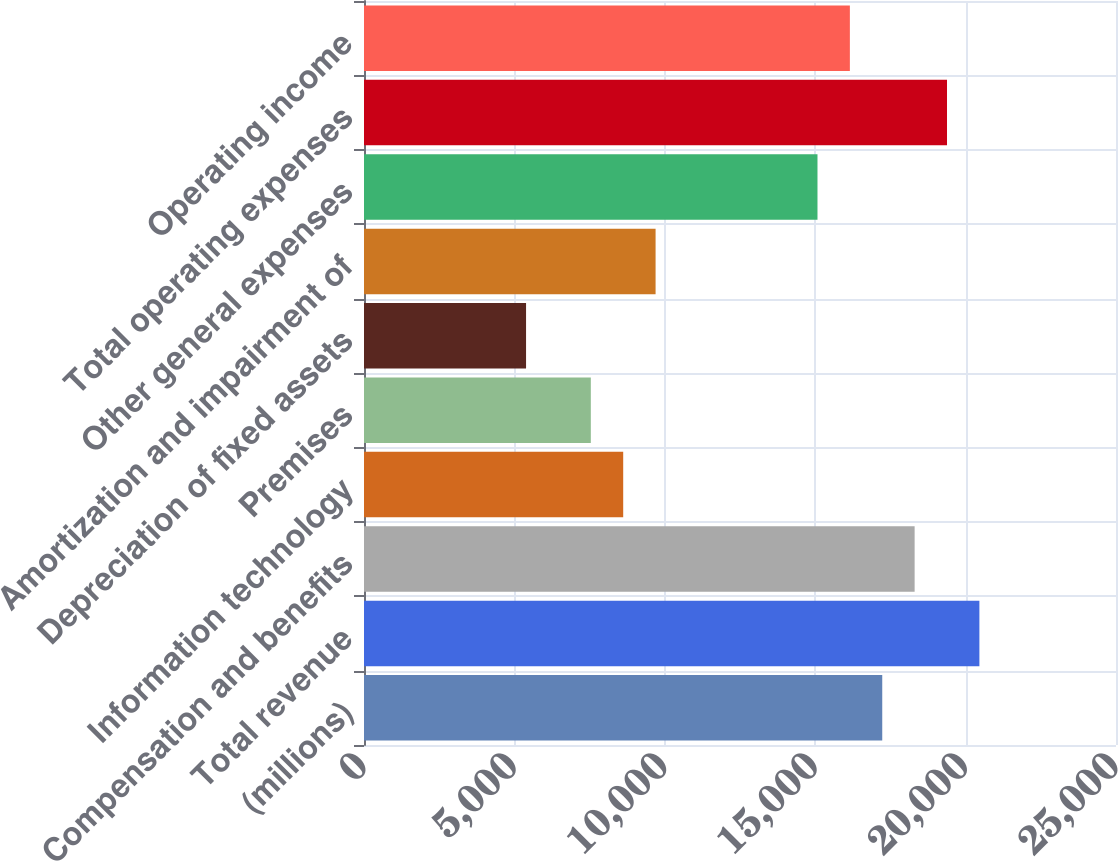Convert chart to OTSL. <chart><loc_0><loc_0><loc_500><loc_500><bar_chart><fcel>(millions)<fcel>Total revenue<fcel>Compensation and benefits<fcel>Information technology<fcel>Premises<fcel>Depreciation of fixed assets<fcel>Amortization and impairment of<fcel>Other general expenses<fcel>Total operating expenses<fcel>Operating income<nl><fcel>17229<fcel>20458.5<fcel>18305.5<fcel>8617<fcel>7540.5<fcel>5387.5<fcel>9693.5<fcel>15076<fcel>19382<fcel>16152.5<nl></chart> 